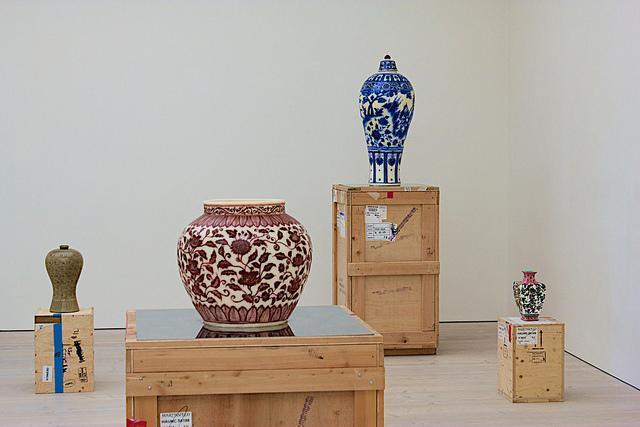How many vases are visible?
Give a very brief answer. 3. 